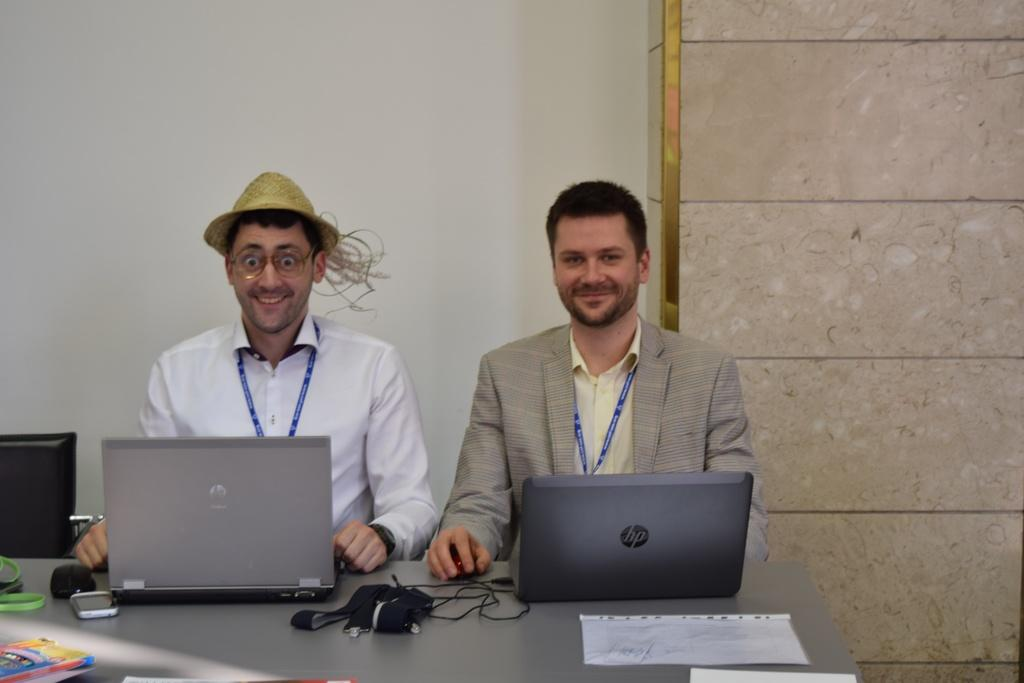What objects are on the table in the image? There are laptops on a table in the image. How many people are in the image? Two persons are present in the image. What are the persons wearing? The persons are wearing shirts. What can be seen in the background of the image? There is a wall in the background of the image. What type of yarn is being used by the persons in the image? There is no yarn present in the image; the persons are wearing shirts, but there is no indication of yarn being used. 